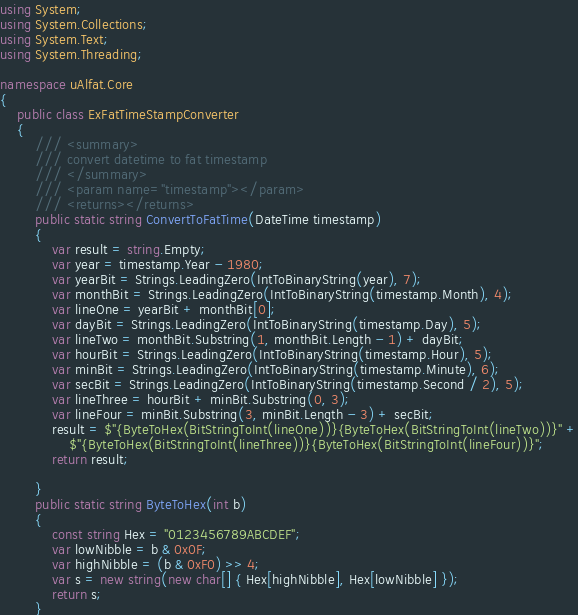<code> <loc_0><loc_0><loc_500><loc_500><_C#_>using System;
using System.Collections;
using System.Text;
using System.Threading;

namespace uAlfat.Core
{
    public class ExFatTimeStampConverter
    {
        /// <summary>
        /// convert datetime to fat timestamp
        /// </summary>
        /// <param name="timestamp"></param>
        /// <returns></returns>
        public static string ConvertToFatTime(DateTime timestamp)
        {
            var result = string.Empty;
            var year = timestamp.Year - 1980;
            var yearBit = Strings.LeadingZero(IntToBinaryString(year), 7);
            var monthBit = Strings.LeadingZero(IntToBinaryString(timestamp.Month), 4);
            var lineOne = yearBit + monthBit[0];
            var dayBit = Strings.LeadingZero(IntToBinaryString(timestamp.Day), 5);
            var lineTwo = monthBit.Substring(1, monthBit.Length - 1) + dayBit;
            var hourBit = Strings.LeadingZero(IntToBinaryString(timestamp.Hour), 5);
            var minBit = Strings.LeadingZero(IntToBinaryString(timestamp.Minute), 6);
            var secBit = Strings.LeadingZero(IntToBinaryString(timestamp.Second / 2), 5);
            var lineThree = hourBit + minBit.Substring(0, 3);
            var lineFour = minBit.Substring(3, minBit.Length - 3) + secBit;
            result = $"{ByteToHex(BitStringToInt(lineOne))}{ByteToHex(BitStringToInt(lineTwo))}" +
                $"{ByteToHex(BitStringToInt(lineThree))}{ByteToHex(BitStringToInt(lineFour))}";
            return result;

        }
        public static string ByteToHex(int b)
        {
            const string Hex = "0123456789ABCDEF";
            var lowNibble = b & 0x0F;
            var highNibble = (b & 0xF0) >> 4;
            var s = new string(new char[] { Hex[highNibble], Hex[lowNibble] });
            return s;
        }
</code> 